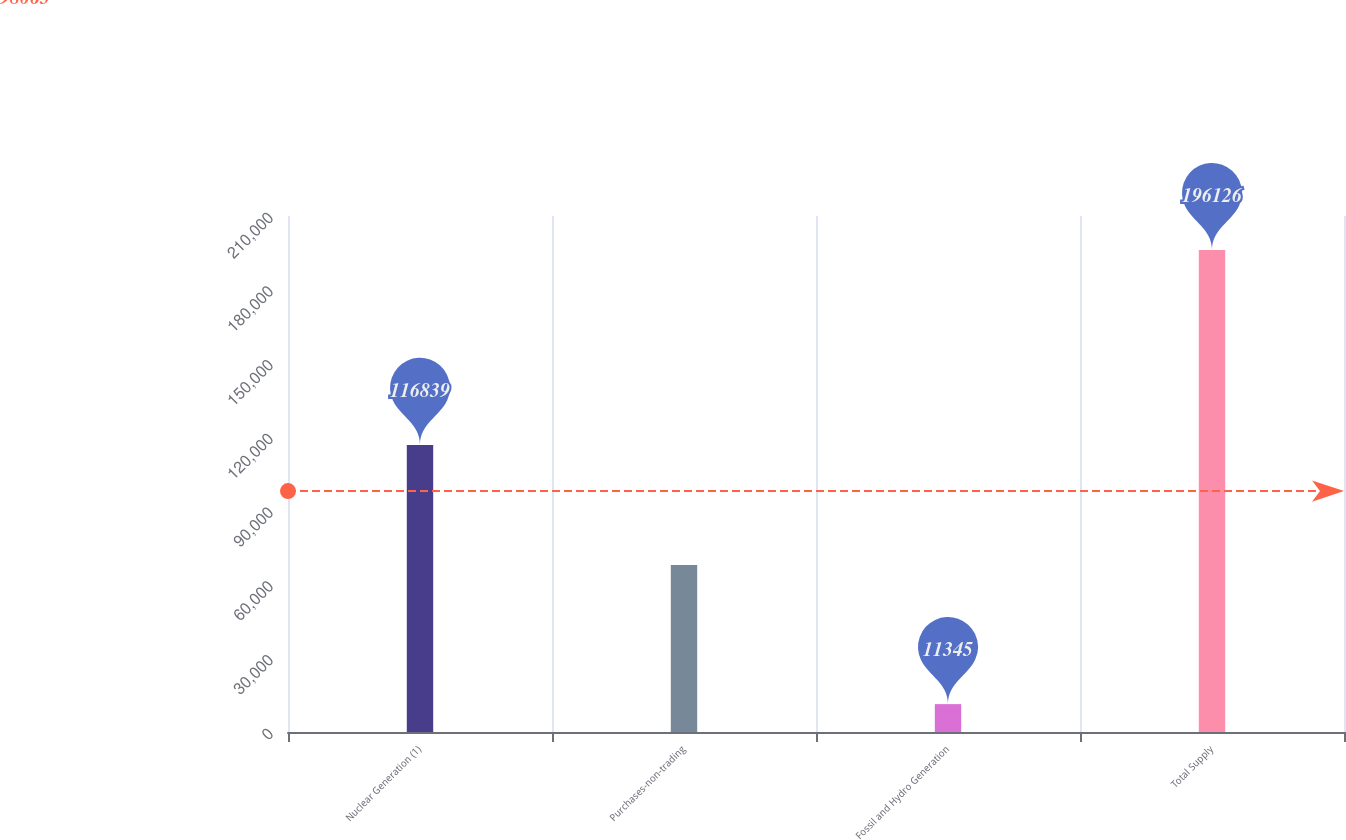Convert chart. <chart><loc_0><loc_0><loc_500><loc_500><bar_chart><fcel>Nuclear Generation (1)<fcel>Purchases-non-trading<fcel>Fossil and Hydro Generation<fcel>Total Supply<nl><fcel>116839<fcel>67942<fcel>11345<fcel>196126<nl></chart> 